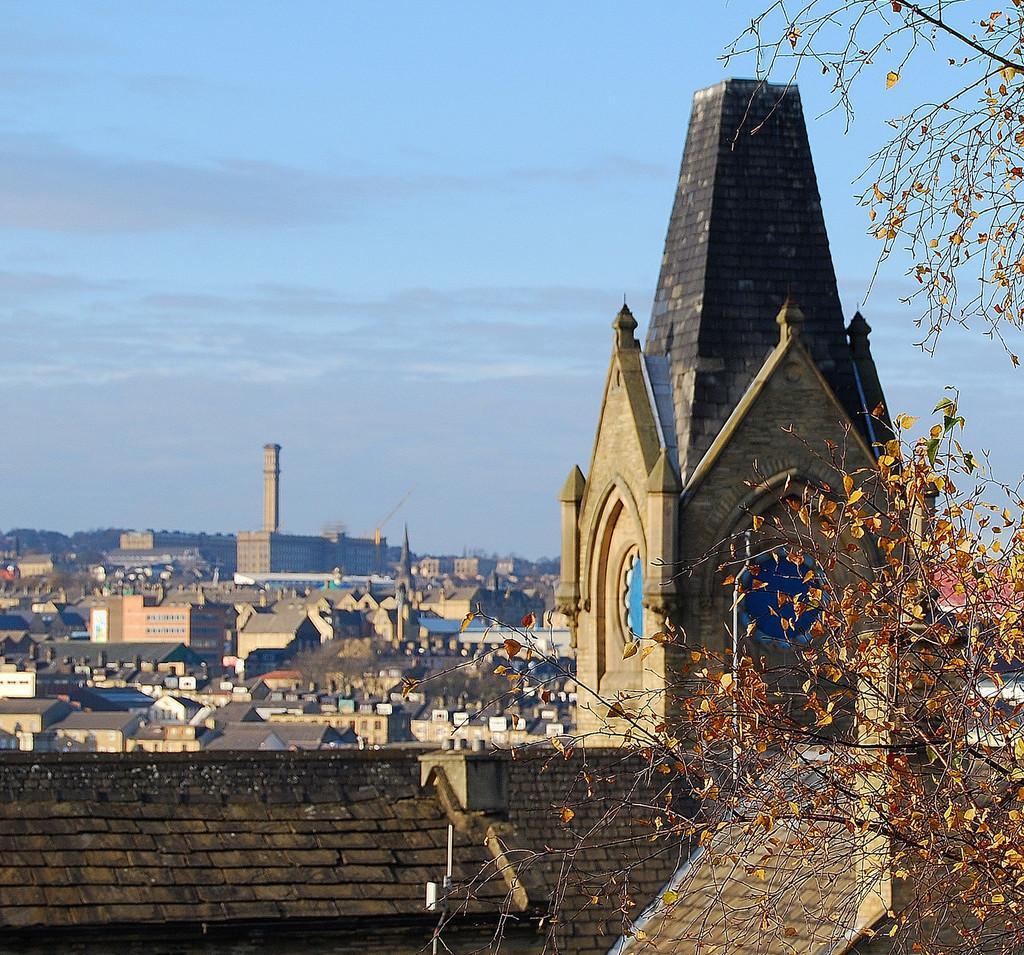Describe this image in one or two sentences. In this image we can able to see some houses, buildings, also we can see a tree, and the sky. 